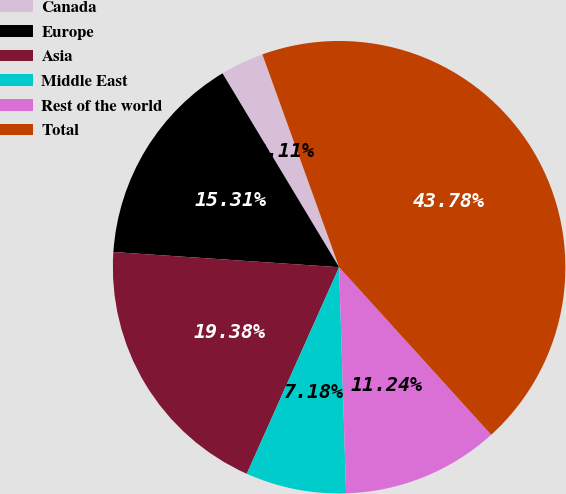Convert chart. <chart><loc_0><loc_0><loc_500><loc_500><pie_chart><fcel>Canada<fcel>Europe<fcel>Asia<fcel>Middle East<fcel>Rest of the world<fcel>Total<nl><fcel>3.11%<fcel>15.31%<fcel>19.38%<fcel>7.18%<fcel>11.24%<fcel>43.78%<nl></chart> 